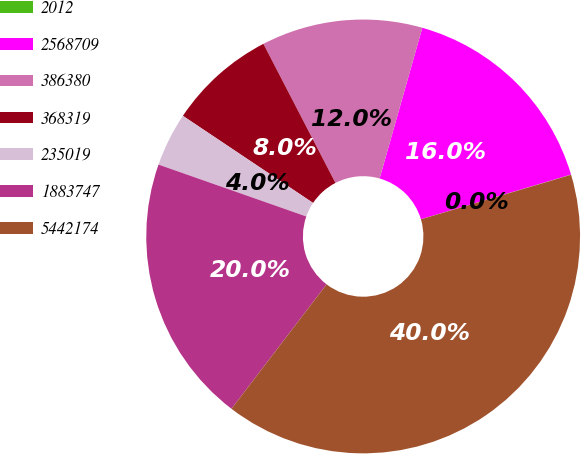Convert chart to OTSL. <chart><loc_0><loc_0><loc_500><loc_500><pie_chart><fcel>2012<fcel>2568709<fcel>386380<fcel>368319<fcel>235019<fcel>1883747<fcel>5442174<nl><fcel>0.02%<fcel>16.0%<fcel>12.0%<fcel>8.01%<fcel>4.01%<fcel>19.99%<fcel>39.97%<nl></chart> 